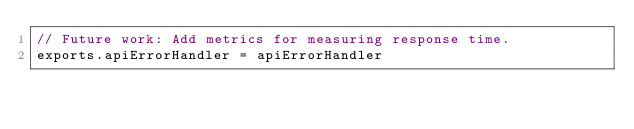Convert code to text. <code><loc_0><loc_0><loc_500><loc_500><_JavaScript_>// Future work: Add metrics for measuring response time.
exports.apiErrorHandler = apiErrorHandler
</code> 